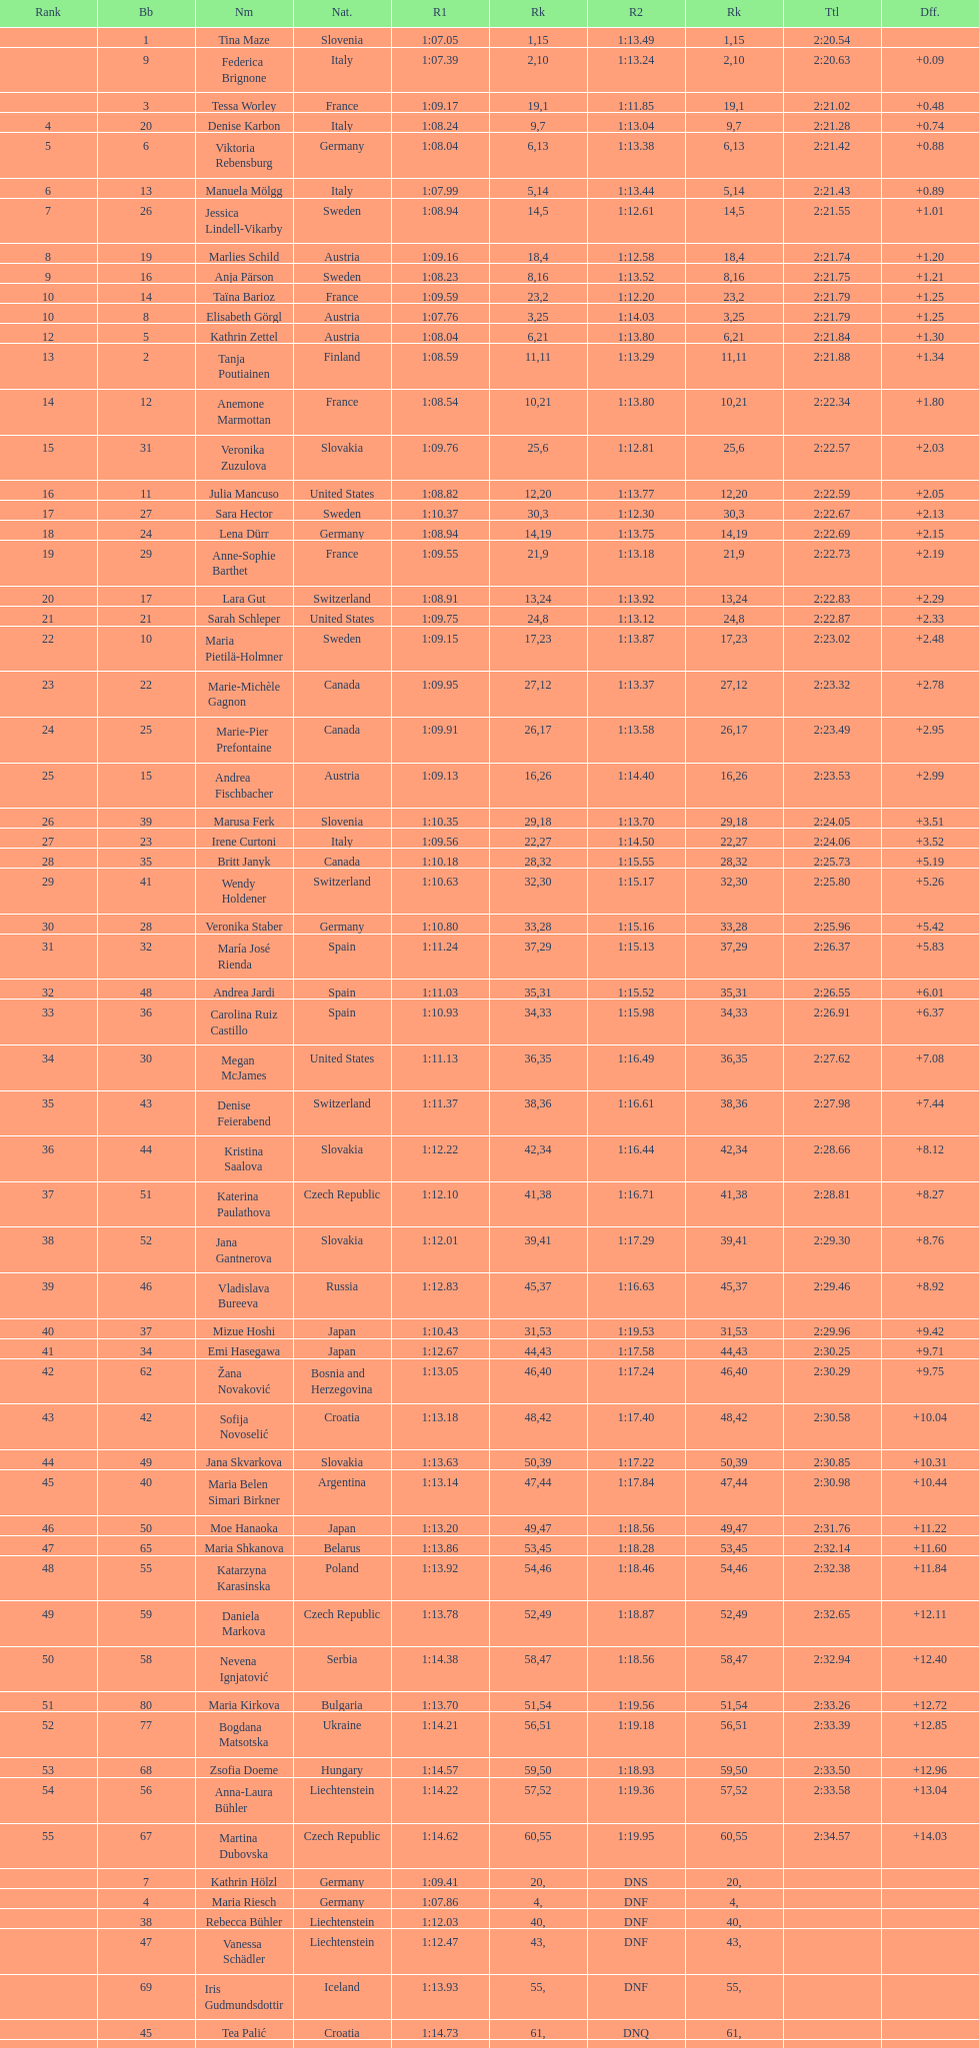Who ranked next after federica brignone? Tessa Worley. 